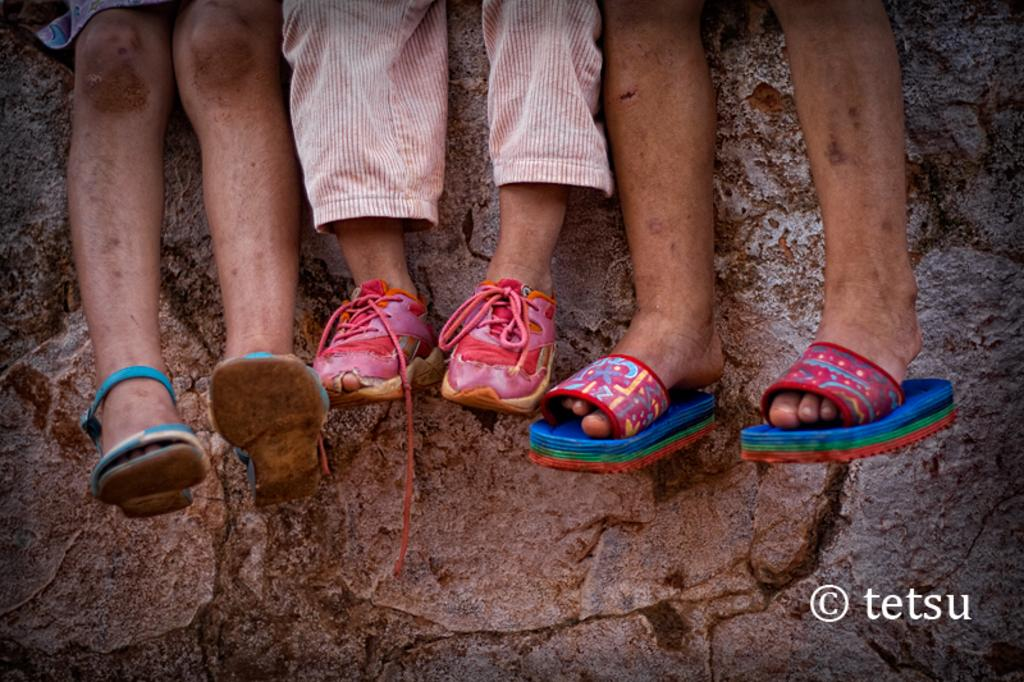What body parts are visible in the image? There are human legs visible in the image. What is covering the feet of the person in the image? A: Footwear is present in the image. What can be seen in the background of the image? There appears to be a rock in the background of the image. Where is the text located in the image? There is text in the bottom right corner of the image. How many snakes are wrapped around the person's legs in the image? There are no snakes present in the image; only human legs and footwear are visible. 